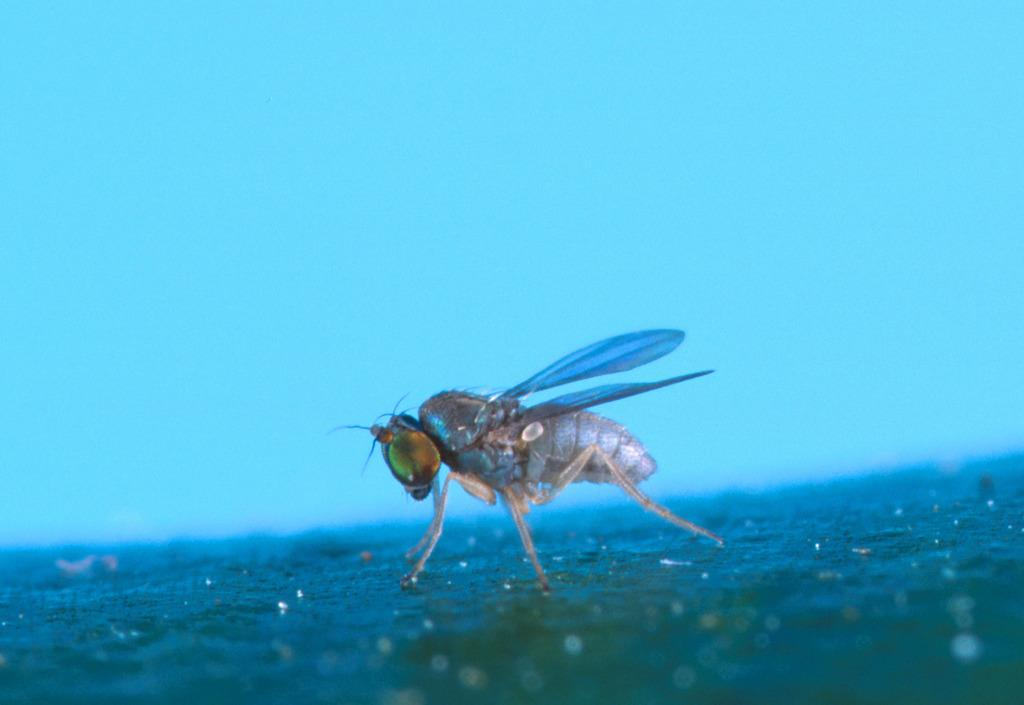What type of creature is in the picture? There is an insect in the picture. What features does the insect have? The insect has wings, legs, and eyes. Where is the table located in the image? There is no table present in the image; it features an insect with wings, legs, and eyes. What does the aunt do in the image? There is no aunt present in the image; it features an insect with wings, legs, and eyes. 